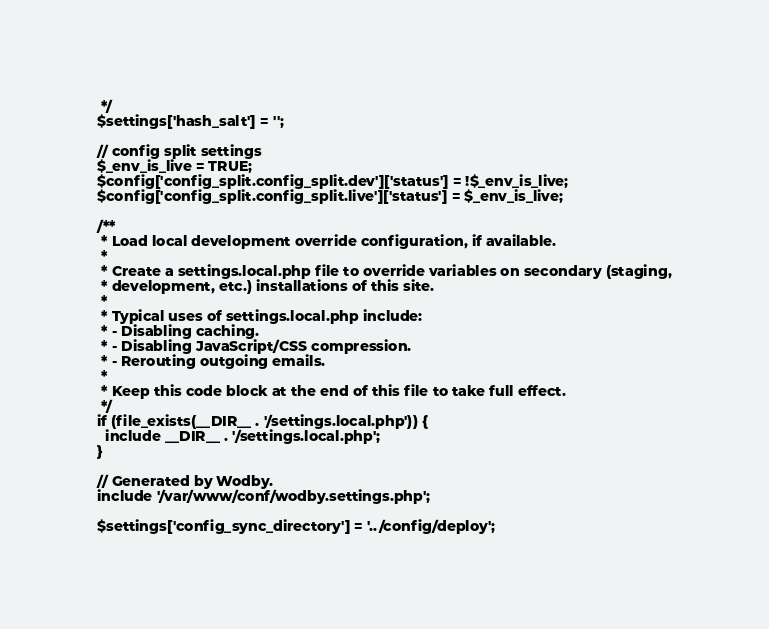<code> <loc_0><loc_0><loc_500><loc_500><_PHP_> */
$settings['hash_salt'] = '';

// config split settings
$_env_is_live = TRUE;
$config['config_split.config_split.dev']['status'] = !$_env_is_live;
$config['config_split.config_split.live']['status'] = $_env_is_live;

/**
 * Load local development override configuration, if available.
 *
 * Create a settings.local.php file to override variables on secondary (staging,
 * development, etc.) installations of this site.
 *
 * Typical uses of settings.local.php include:
 * - Disabling caching.
 * - Disabling JavaScript/CSS compression.
 * - Rerouting outgoing emails.
 *
 * Keep this code block at the end of this file to take full effect.
 */
if (file_exists(__DIR__ . '/settings.local.php')) {
  include __DIR__ . '/settings.local.php';
}

// Generated by Wodby.
include '/var/www/conf/wodby.settings.php';

$settings['config_sync_directory'] = '../config/deploy';
</code> 